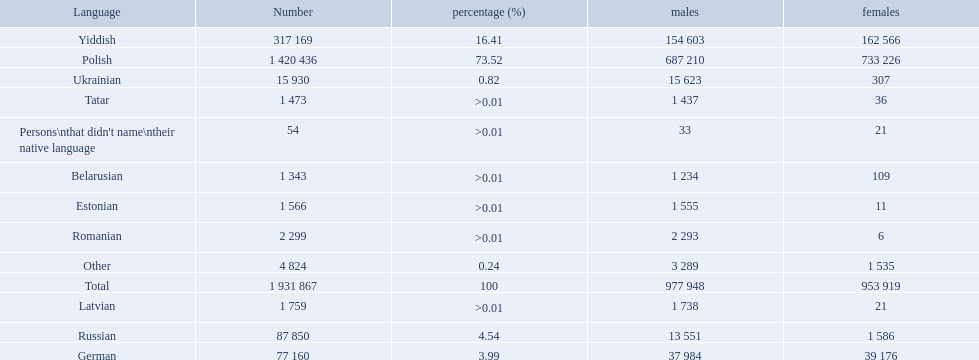Which languages are spoken by more than 50,000 people? Polish, Yiddish, Russian, German. Would you be able to parse every entry in this table? {'header': ['Language', 'Number', 'percentage (%)', 'males', 'females'], 'rows': [['Yiddish', '317 169', '16.41', '154 603', '162 566'], ['Polish', '1 420 436', '73.52', '687 210', '733 226'], ['Ukrainian', '15 930', '0.82', '15 623', '307'], ['Tatar', '1 473', '>0.01', '1 437', '36'], ["Persons\\nthat didn't name\\ntheir native language", '54', '>0.01', '33', '21'], ['Belarusian', '1 343', '>0.01', '1 234', '109'], ['Estonian', '1 566', '>0.01', '1 555', '11'], ['Romanian', '2 299', '>0.01', '2 293', '6'], ['Other', '4 824', '0.24', '3 289', '1 535'], ['Total', '1 931 867', '100', '977 948', '953 919'], ['Latvian', '1 759', '>0.01', '1 738', '21'], ['Russian', '87 850', '4.54', '13 551', '1 586'], ['German', '77 160', '3.99', '37 984', '39 176']]} Of these languages, which ones are spoken by less than 15% of the population? Russian, German. Of the remaining two, which one is spoken by 37,984 males? German. What were all the languages? Polish, Yiddish, Russian, German, Ukrainian, Romanian, Latvian, Estonian, Tatar, Belarusian, Other, Persons\nthat didn't name\ntheir native language. For these, how many people spoke them? 1 420 436, 317 169, 87 850, 77 160, 15 930, 2 299, 1 759, 1 566, 1 473, 1 343, 4 824, 54. Of these, which is the largest number of speakers? 1 420 436. Which language corresponds to this number? Polish. How many languages are there? Polish, Yiddish, Russian, German, Ukrainian, Romanian, Latvian, Estonian, Tatar, Belarusian. Which language do more people speak? Polish. 